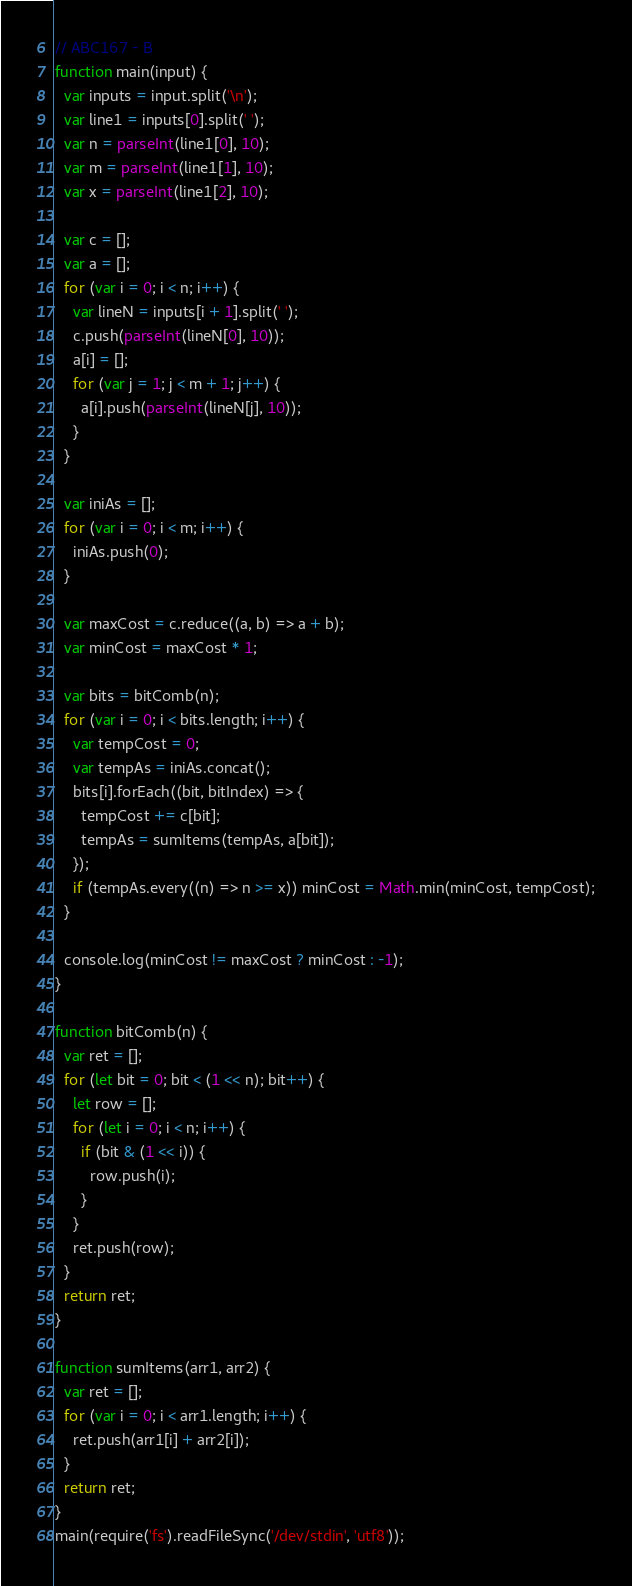<code> <loc_0><loc_0><loc_500><loc_500><_JavaScript_>// ABC167 - B
function main(input) {
  var inputs = input.split('\n');
  var line1 = inputs[0].split(' ');
  var n = parseInt(line1[0], 10);
  var m = parseInt(line1[1], 10);
  var x = parseInt(line1[2], 10);

  var c = [];
  var a = [];
  for (var i = 0; i < n; i++) {
    var lineN = inputs[i + 1].split(' ');
    c.push(parseInt(lineN[0], 10));
    a[i] = [];
    for (var j = 1; j < m + 1; j++) {
      a[i].push(parseInt(lineN[j], 10));
    }
  }

  var iniAs = [];
  for (var i = 0; i < m; i++) {
    iniAs.push(0);
  }

  var maxCost = c.reduce((a, b) => a + b);
  var minCost = maxCost * 1;

  var bits = bitComb(n);
  for (var i = 0; i < bits.length; i++) {
    var tempCost = 0;
    var tempAs = iniAs.concat();
    bits[i].forEach((bit, bitIndex) => {
      tempCost += c[bit];
      tempAs = sumItems(tempAs, a[bit]);
    });
    if (tempAs.every((n) => n >= x)) minCost = Math.min(minCost, tempCost);
  }

  console.log(minCost != maxCost ? minCost : -1);
}

function bitComb(n) {
  var ret = [];
  for (let bit = 0; bit < (1 << n); bit++) {
    let row = [];
    for (let i = 0; i < n; i++) {
      if (bit & (1 << i)) {
        row.push(i);
      }
    }
    ret.push(row);
  }
  return ret;
}

function sumItems(arr1, arr2) {
  var ret = [];
  for (var i = 0; i < arr1.length; i++) {
    ret.push(arr1[i] + arr2[i]);
  }
  return ret;
}
main(require('fs').readFileSync('/dev/stdin', 'utf8'));
</code> 